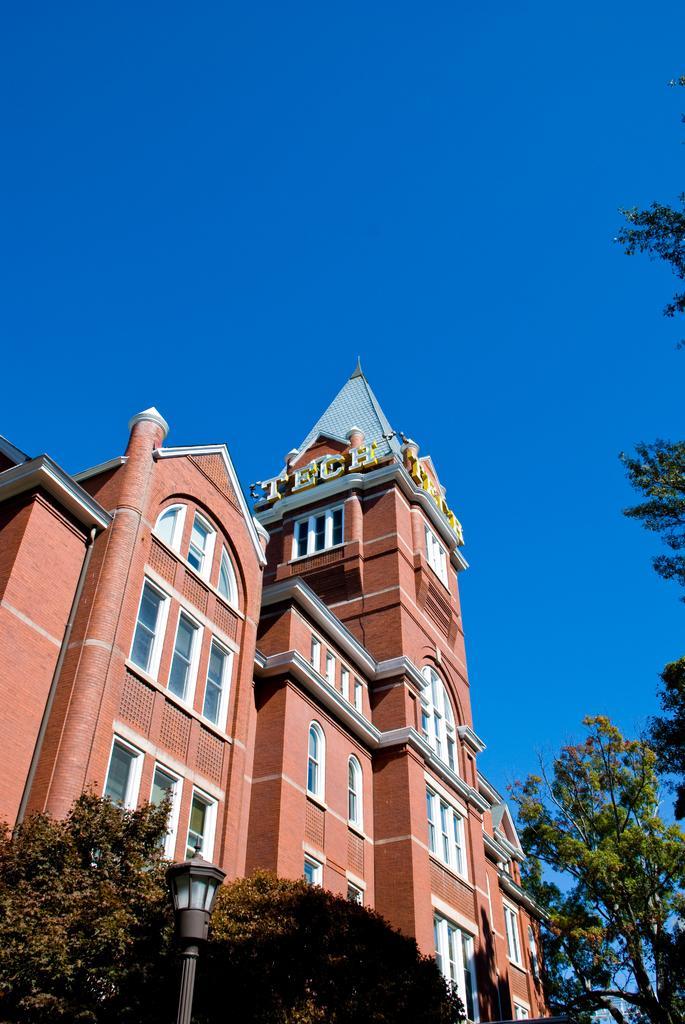In one or two sentences, can you explain what this image depicts? In the image there is a tall building and around the building there are few trees and there is a pole light in front of the trees on the left side. 